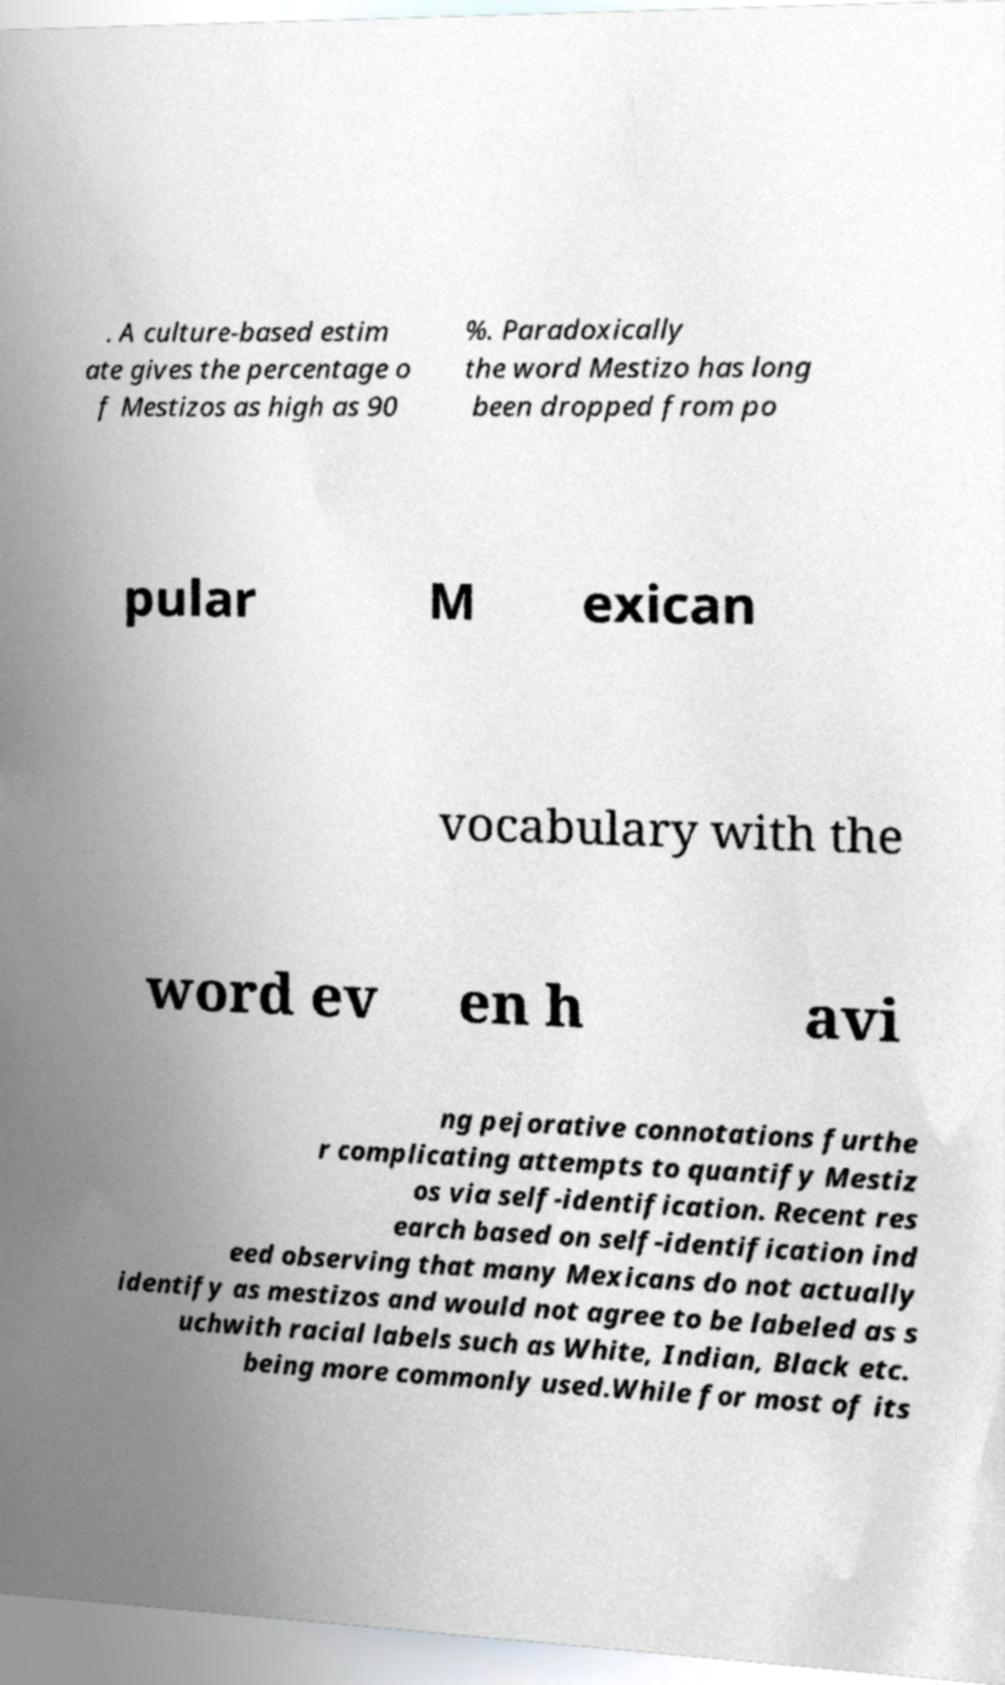Please read and relay the text visible in this image. What does it say? . A culture-based estim ate gives the percentage o f Mestizos as high as 90 %. Paradoxically the word Mestizo has long been dropped from po pular M exican vocabulary with the word ev en h avi ng pejorative connotations furthe r complicating attempts to quantify Mestiz os via self-identification. Recent res earch based on self-identification ind eed observing that many Mexicans do not actually identify as mestizos and would not agree to be labeled as s uchwith racial labels such as White, Indian, Black etc. being more commonly used.While for most of its 